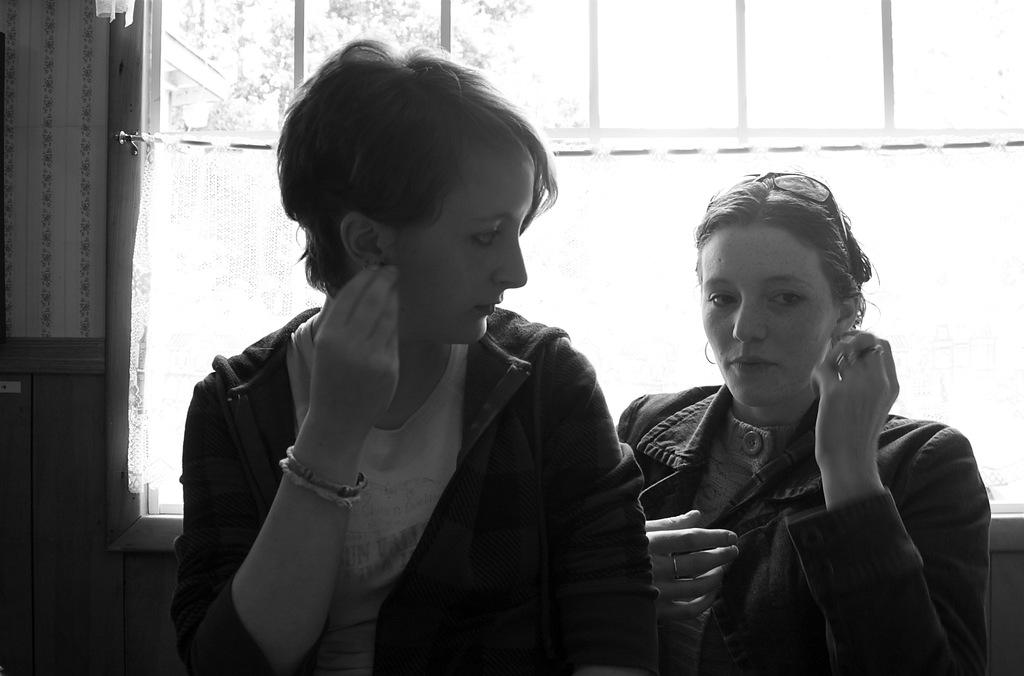How many people are present in the image? There are two people in the image. What are the people wearing? Both people are wearing jackets. What is the relationship between the two people in the image? One woman is looking at another woman. What can be seen in the background of the image? There is a window in the background of the image. What type of kitten can be seen playing with a brick in the image? There is no kitten or brick present in the image. What is the cork used for in the image? There is no cork present in the image. 